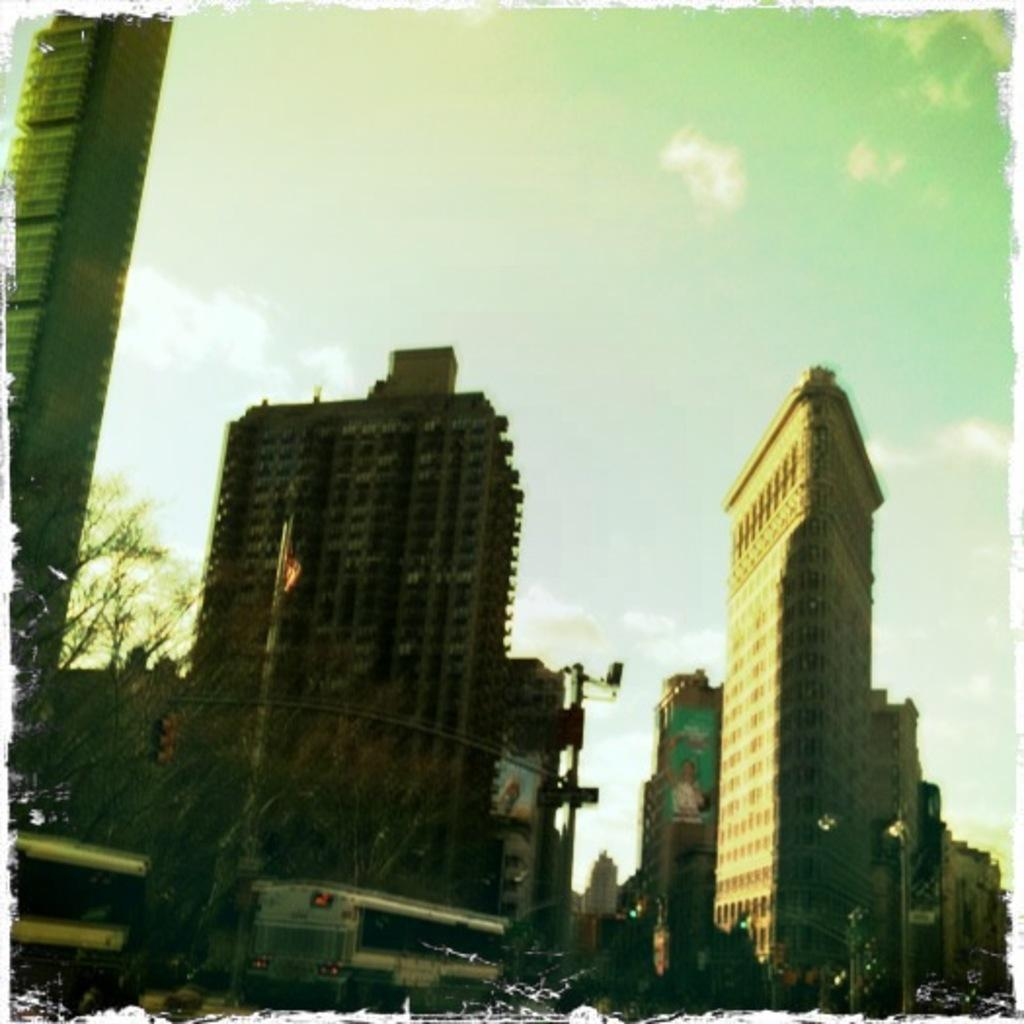What type of structures can be seen in the image? There are buildings in the image. What else is present in the image besides buildings? There are vehicles and poles in the image, as well as other objects. What can be seen in the background of the image? The sky is visible in the background of the image. What type of meal is being prepared on the pole in the image? There is no meal being prepared in the image, and no pole is mentioned as having a meal associated with it. 